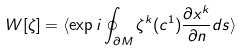<formula> <loc_0><loc_0><loc_500><loc_500>W [ \zeta ] = \langle \exp i \oint _ { \partial M } \zeta ^ { k } ( c ^ { 1 } ) \frac { \partial x ^ { k } } { \partial n } d s \rangle</formula> 